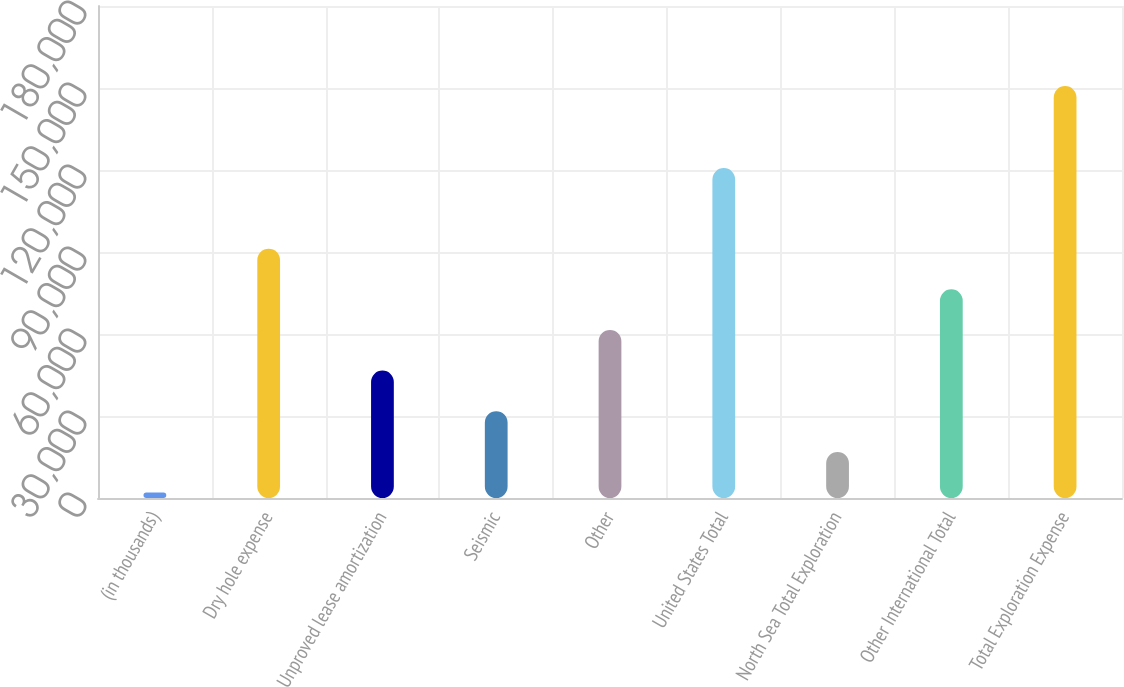Convert chart to OTSL. <chart><loc_0><loc_0><loc_500><loc_500><bar_chart><fcel>(in thousands)<fcel>Dry hole expense<fcel>Unproved lease amortization<fcel>Seismic<fcel>Other<fcel>United States Total<fcel>North Sea Total Exploration<fcel>Other International Total<fcel>Total Exploration Expense<nl><fcel>2002<fcel>91221.4<fcel>46611.7<fcel>31741.8<fcel>61481.6<fcel>120695<fcel>16871.9<fcel>76351.5<fcel>150701<nl></chart> 